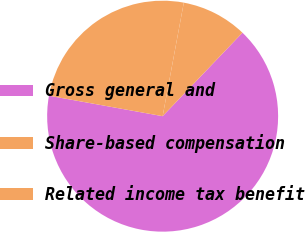<chart> <loc_0><loc_0><loc_500><loc_500><pie_chart><fcel>Gross general and<fcel>Share-based compensation<fcel>Related income tax benefit<nl><fcel>65.69%<fcel>25.1%<fcel>9.21%<nl></chart> 